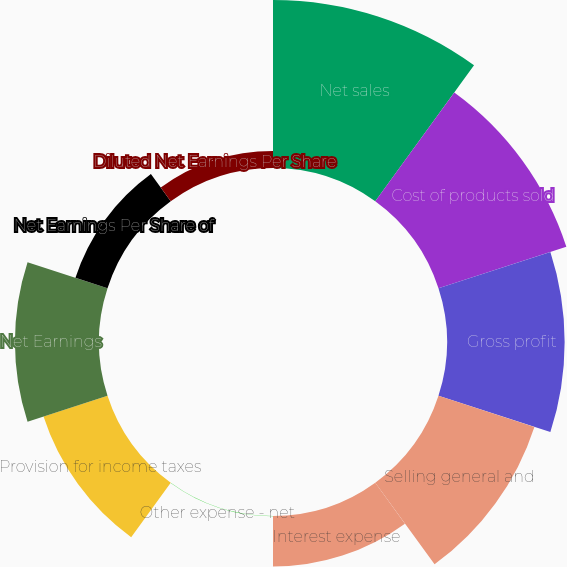Convert chart to OTSL. <chart><loc_0><loc_0><loc_500><loc_500><pie_chart><fcel>Net sales<fcel>Cost of products sold<fcel>Gross profit<fcel>Selling general and<fcel>Interest expense<fcel>Other expense - net<fcel>Provision for income taxes<fcel>Net Earnings<fcel>Net Earnings Per Share of<fcel>Diluted Net Earnings Per Share<nl><fcel>21.72%<fcel>17.38%<fcel>15.21%<fcel>13.04%<fcel>6.53%<fcel>0.02%<fcel>8.7%<fcel>10.87%<fcel>4.36%<fcel>2.19%<nl></chart> 